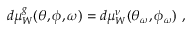<formula> <loc_0><loc_0><loc_500><loc_500>d \mu _ { W } ^ { g } ( \theta , \phi , \omega ) = d \mu _ { W } ^ { \nu } ( \theta _ { \omega } , \phi _ { \omega } ) \ ,</formula> 